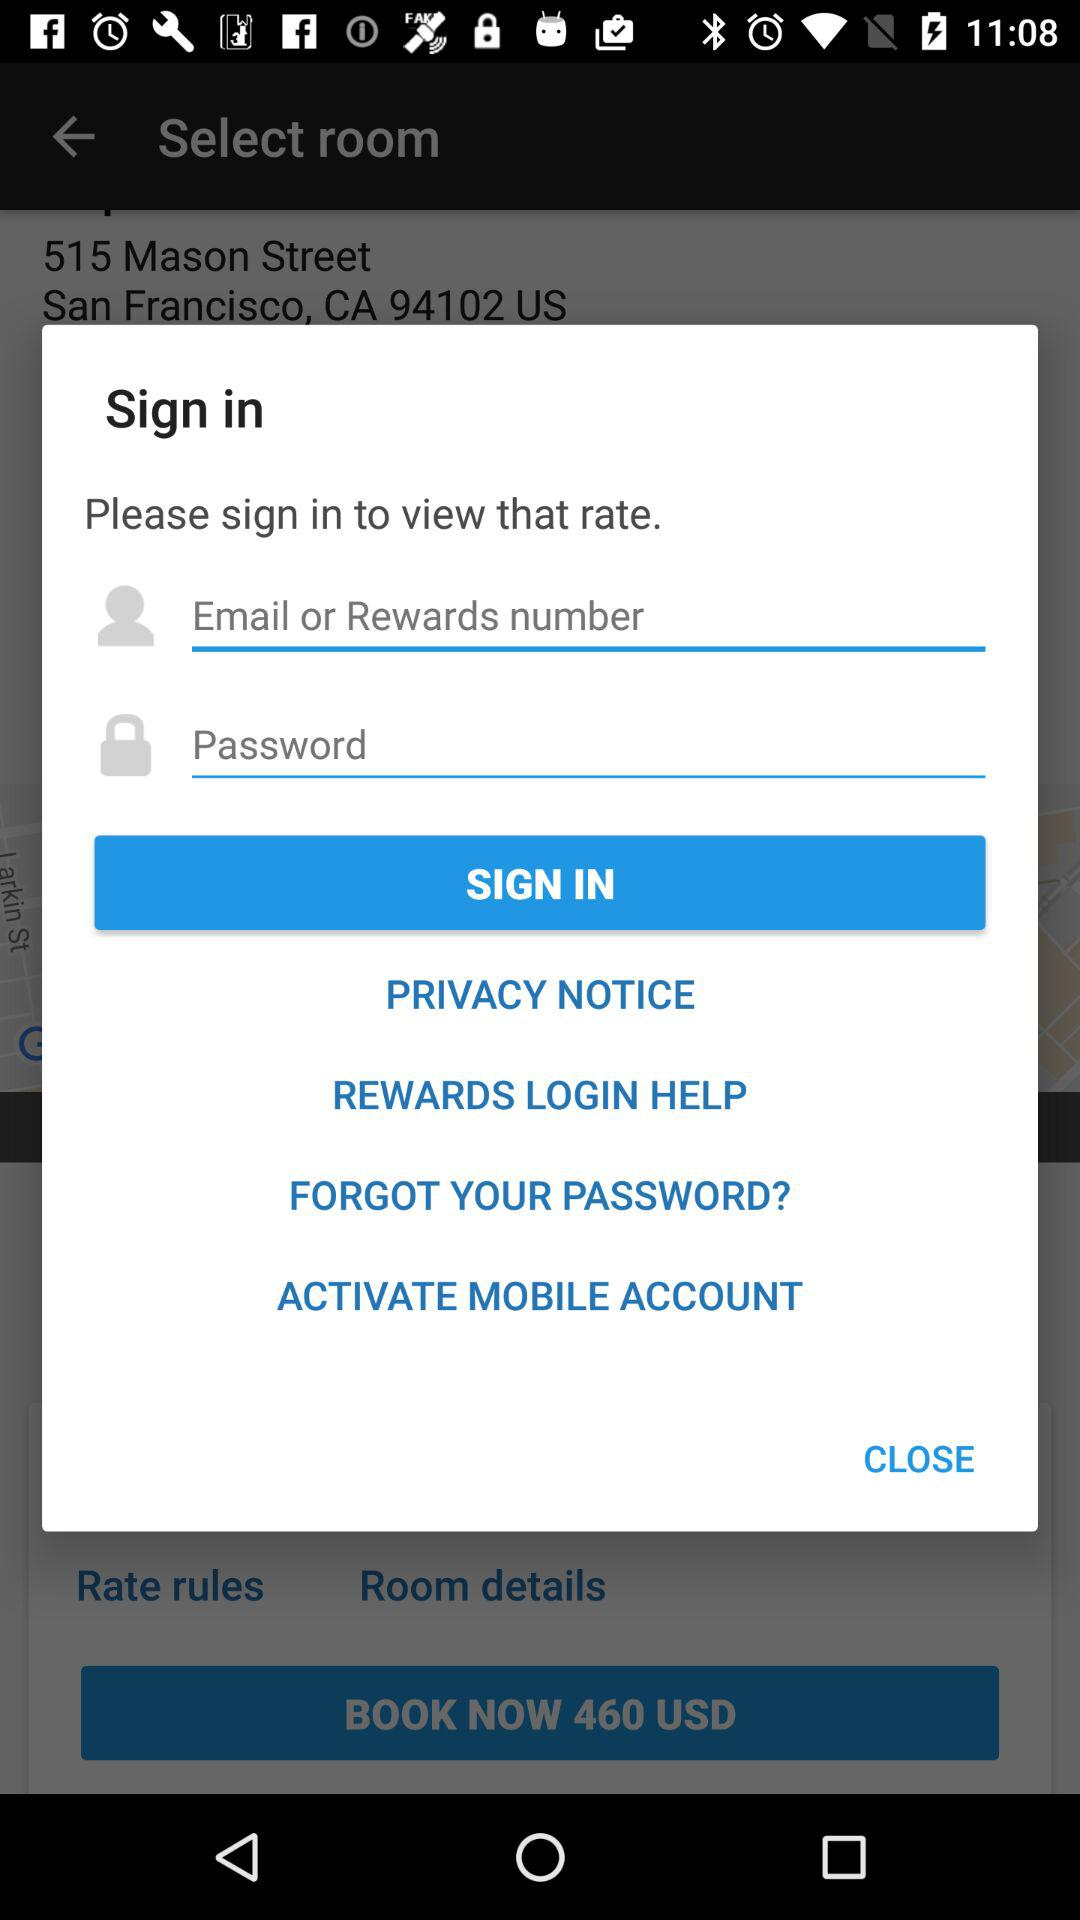How many input fields are on this screen?
Answer the question using a single word or phrase. 2 